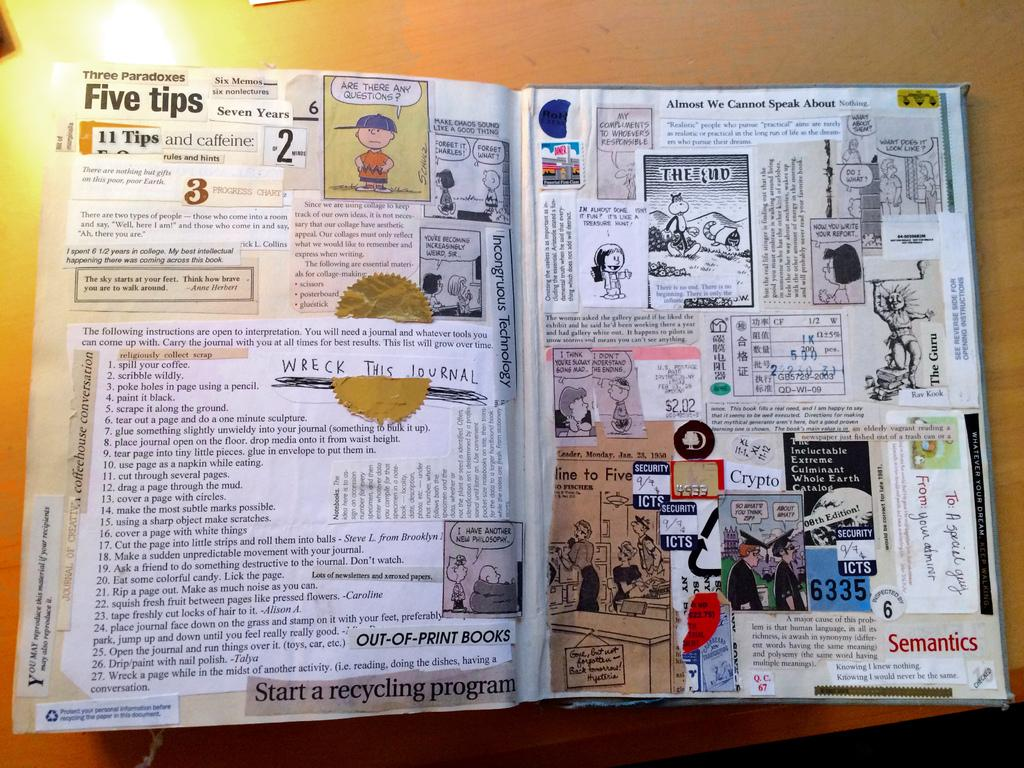What is placed on the table in the image? There is a book placed on the table. What else is placed on the table besides the book? There are posters placed on the table. What type of sticks can be seen holding up the posters on the table? There are no sticks visible in the image; the posters are simply placed on the table. What texture can be felt on the knife in the image? There is no knife present in the image. 